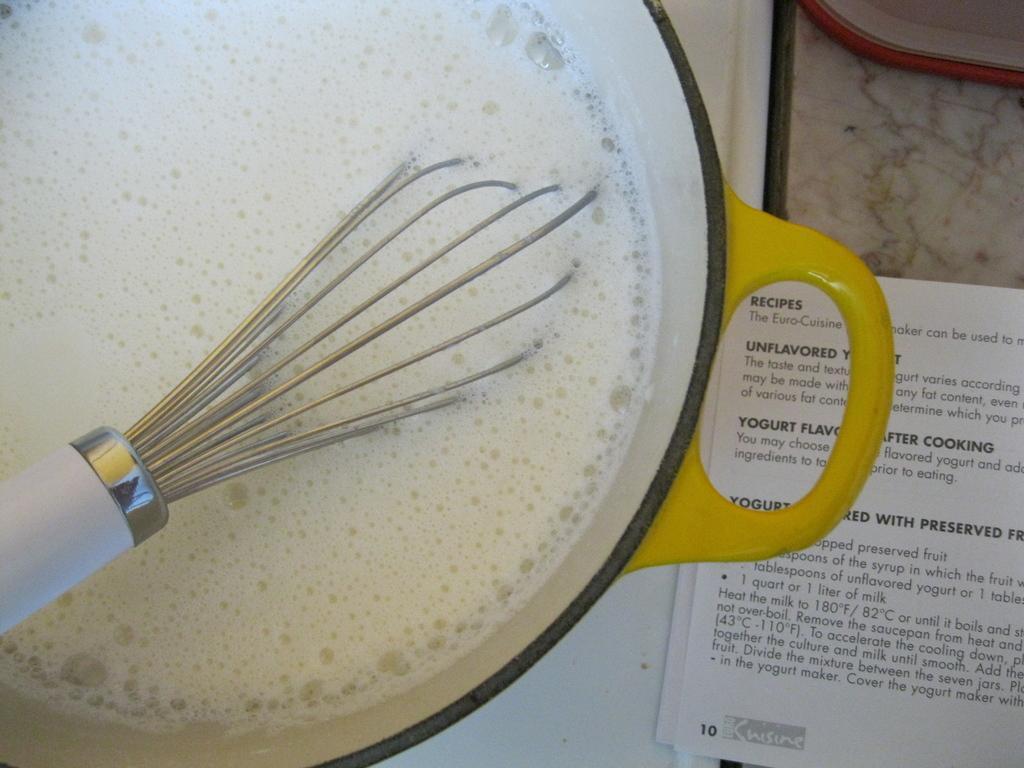Can you describe this image briefly? In this image we can see a bowl in which there is liquid which is in white color and we can see a churner in it, on right side of the image there is a paper on the surface. 